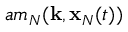Convert formula to latex. <formula><loc_0><loc_0><loc_500><loc_500>a m _ { N } ( { k } , { x } _ { N } ( t ) )</formula> 